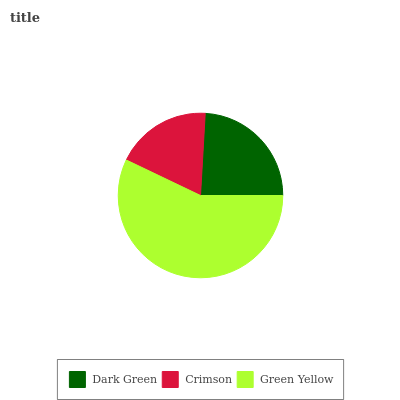Is Crimson the minimum?
Answer yes or no. Yes. Is Green Yellow the maximum?
Answer yes or no. Yes. Is Green Yellow the minimum?
Answer yes or no. No. Is Crimson the maximum?
Answer yes or no. No. Is Green Yellow greater than Crimson?
Answer yes or no. Yes. Is Crimson less than Green Yellow?
Answer yes or no. Yes. Is Crimson greater than Green Yellow?
Answer yes or no. No. Is Green Yellow less than Crimson?
Answer yes or no. No. Is Dark Green the high median?
Answer yes or no. Yes. Is Dark Green the low median?
Answer yes or no. Yes. Is Green Yellow the high median?
Answer yes or no. No. Is Crimson the low median?
Answer yes or no. No. 